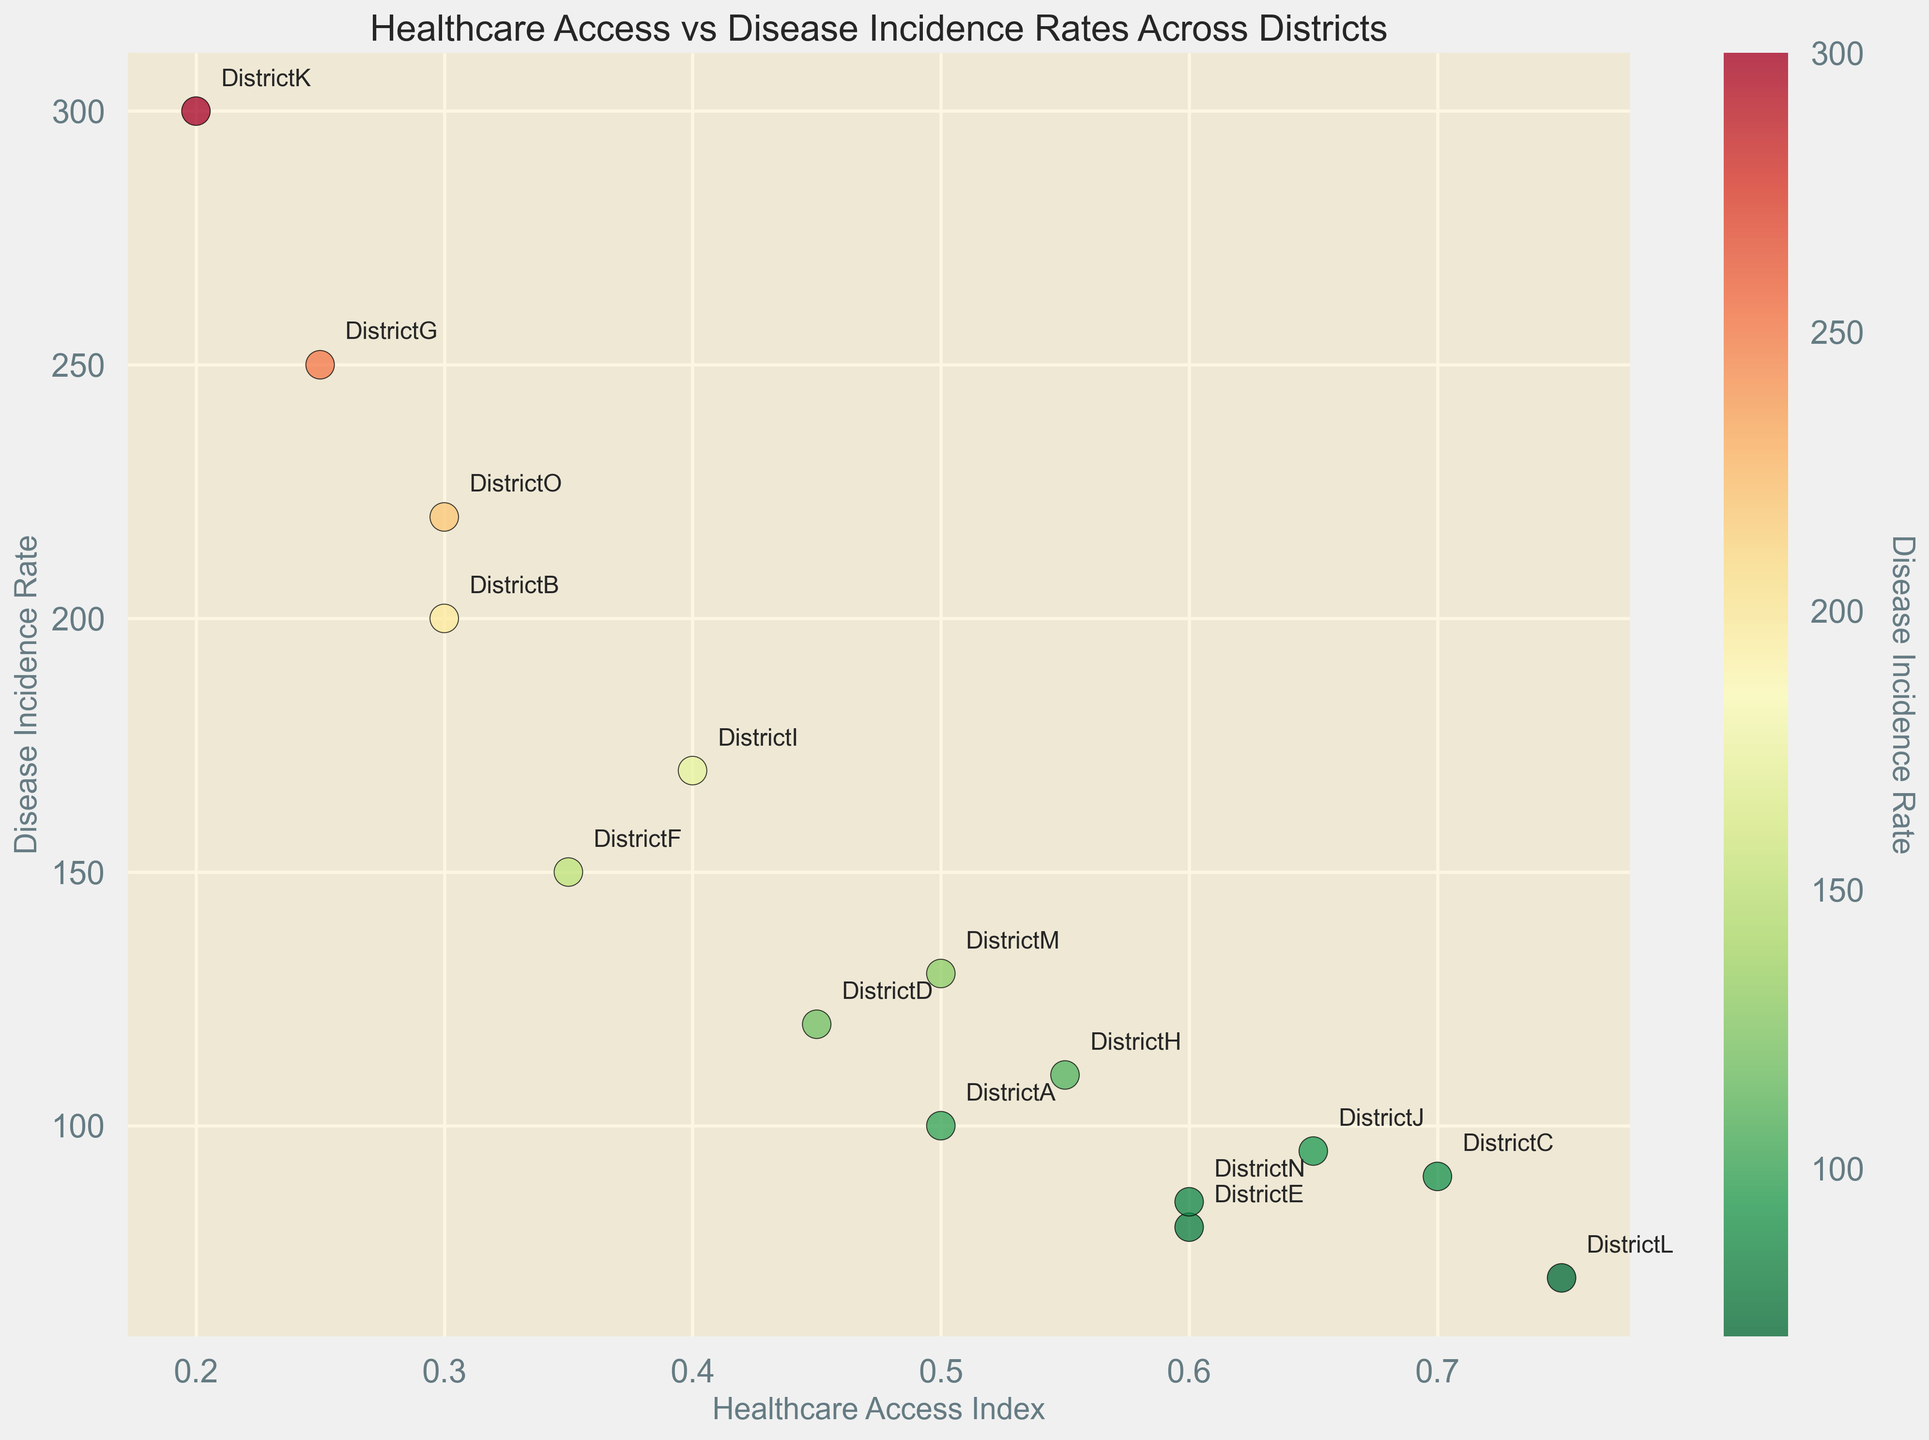What is the disease incidence rate in the district with the highest healthcare access index? First, identify the district with the highest healthcare access index, which is District L with an index of 0.75. Then, locate its corresponding disease incidence rate, which is 70.
Answer: 70 Which district has the lowest healthcare access index and what is its disease incidence rate? Find the district with the lowest healthcare access index, which is District K with an index of 0.20. Then, check its disease incidence rate, which is 300.
Answer: District K with 300 How many districts have a healthcare access index above 0.60 and what are their average disease incidence rates? Districts C, J, and L have healthcare access indices above 0.60. Their disease incidence rates are 90, 95, and 70, respectively. The average rate is (90 + 95 + 70) / 3 = 85.
Answer: 3 districts; 85 What is the difference in disease incidence rate between the district with the highest rate and the district with the lowest rate? The district with the highest rate is District K (300) and with the lowest rate is District L (70). The difference is 300 - 70 = 230.
Answer: 230 Which districts have a healthcare access index below 0.40 and what are their disease incidence rates? The districts with a healthcare access index below 0.40 are District B (200), District F (150), District G (250), and District K (300).
Answer: Districts B, F, G, K; rates are 200, 150, 250, 300 Between Districts A and M, which one has a higher disease incidence rate, and by how much? District A has a disease incidence rate of 100 and District M has a rate of 130. The difference is 130 - 100 = 30.
Answer: District M; by 30 What pattern emerges when comparing healthcare access index to disease incidence rate? Generally, there is an inverse relationship: districts with higher healthcare access indices tend to have lower disease incidence rates, and vice versa.
Answer: Inverse relationship How many districts have a disease incidence rate above 150, and what are their corresponding healthcare access indices? Four districts have a rate above 150: District B (0.30), District G (0.25), District I (0.40), and District K (0.20).
Answer: 4 districts; indices are 0.30, 0.25, 0.40, 0.20 What color on the heatmap indicates the highest disease incidence rates, and which districts are in that color range? The color representing the highest disease incidence rates is the reddest. Districts G and K are in this color range with rates of 250 and 300, respectively.
Answer: Red; Districts G, K 